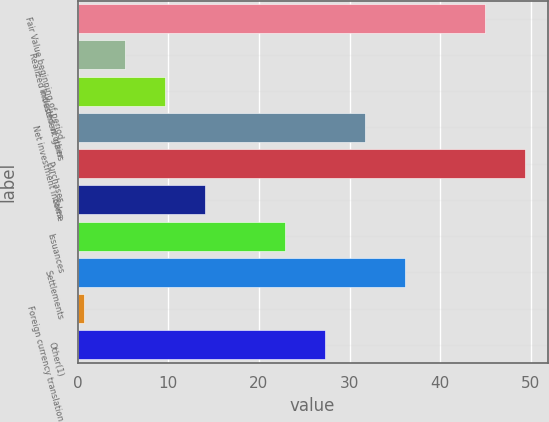Convert chart. <chart><loc_0><loc_0><loc_500><loc_500><bar_chart><fcel>Fair Value beginning of period<fcel>Realized investment gains<fcel>Included in other<fcel>Net investment income<fcel>Purchases<fcel>Sales<fcel>Issuances<fcel>Settlements<fcel>Foreign currency translation<fcel>Other(1)<nl><fcel>44.96<fcel>5.18<fcel>9.6<fcel>31.7<fcel>49.38<fcel>14.02<fcel>22.86<fcel>36.12<fcel>0.76<fcel>27.28<nl></chart> 